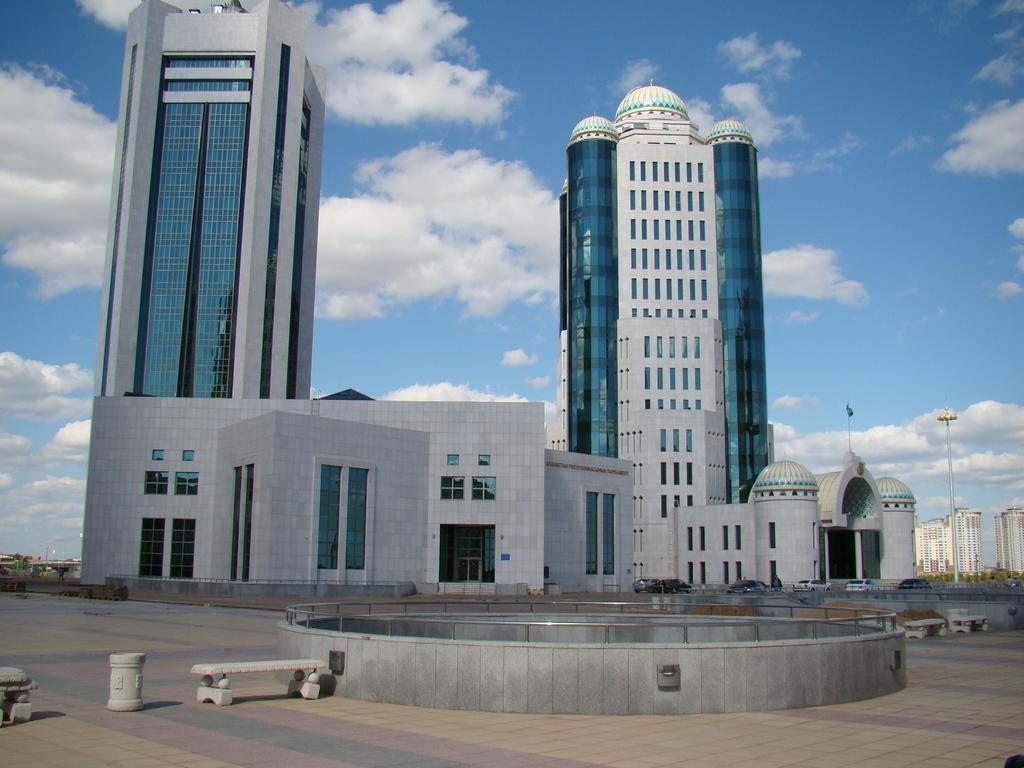Could you give a brief overview of what you see in this image? In the foreground of this image, there are stone benches on the path and a tiny circular wall. In the background, there are buildings, a flag on the building, pole, sky and the cloud. 